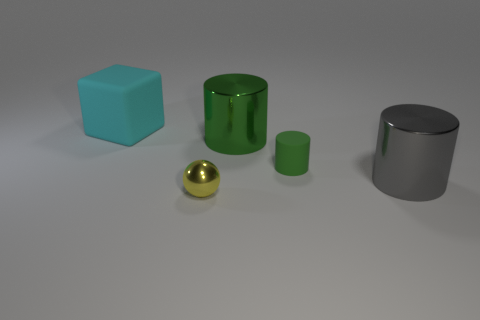Add 4 rubber things. How many objects exist? 9 Subtract all cubes. How many objects are left? 4 Subtract 1 green cylinders. How many objects are left? 4 Subtract all small brown shiny blocks. Subtract all big gray cylinders. How many objects are left? 4 Add 5 small yellow metallic spheres. How many small yellow metallic spheres are left? 6 Add 5 green rubber objects. How many green rubber objects exist? 6 